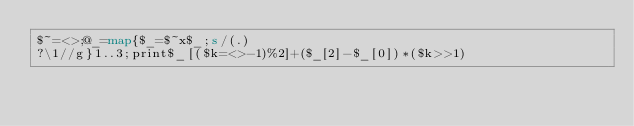<code> <loc_0><loc_0><loc_500><loc_500><_Perl_>$~=<>;@_=map{$_=$~x$_;s/(.)
?\1//g}1..3;print$_[($k=<>-1)%2]+($_[2]-$_[0])*($k>>1)</code> 